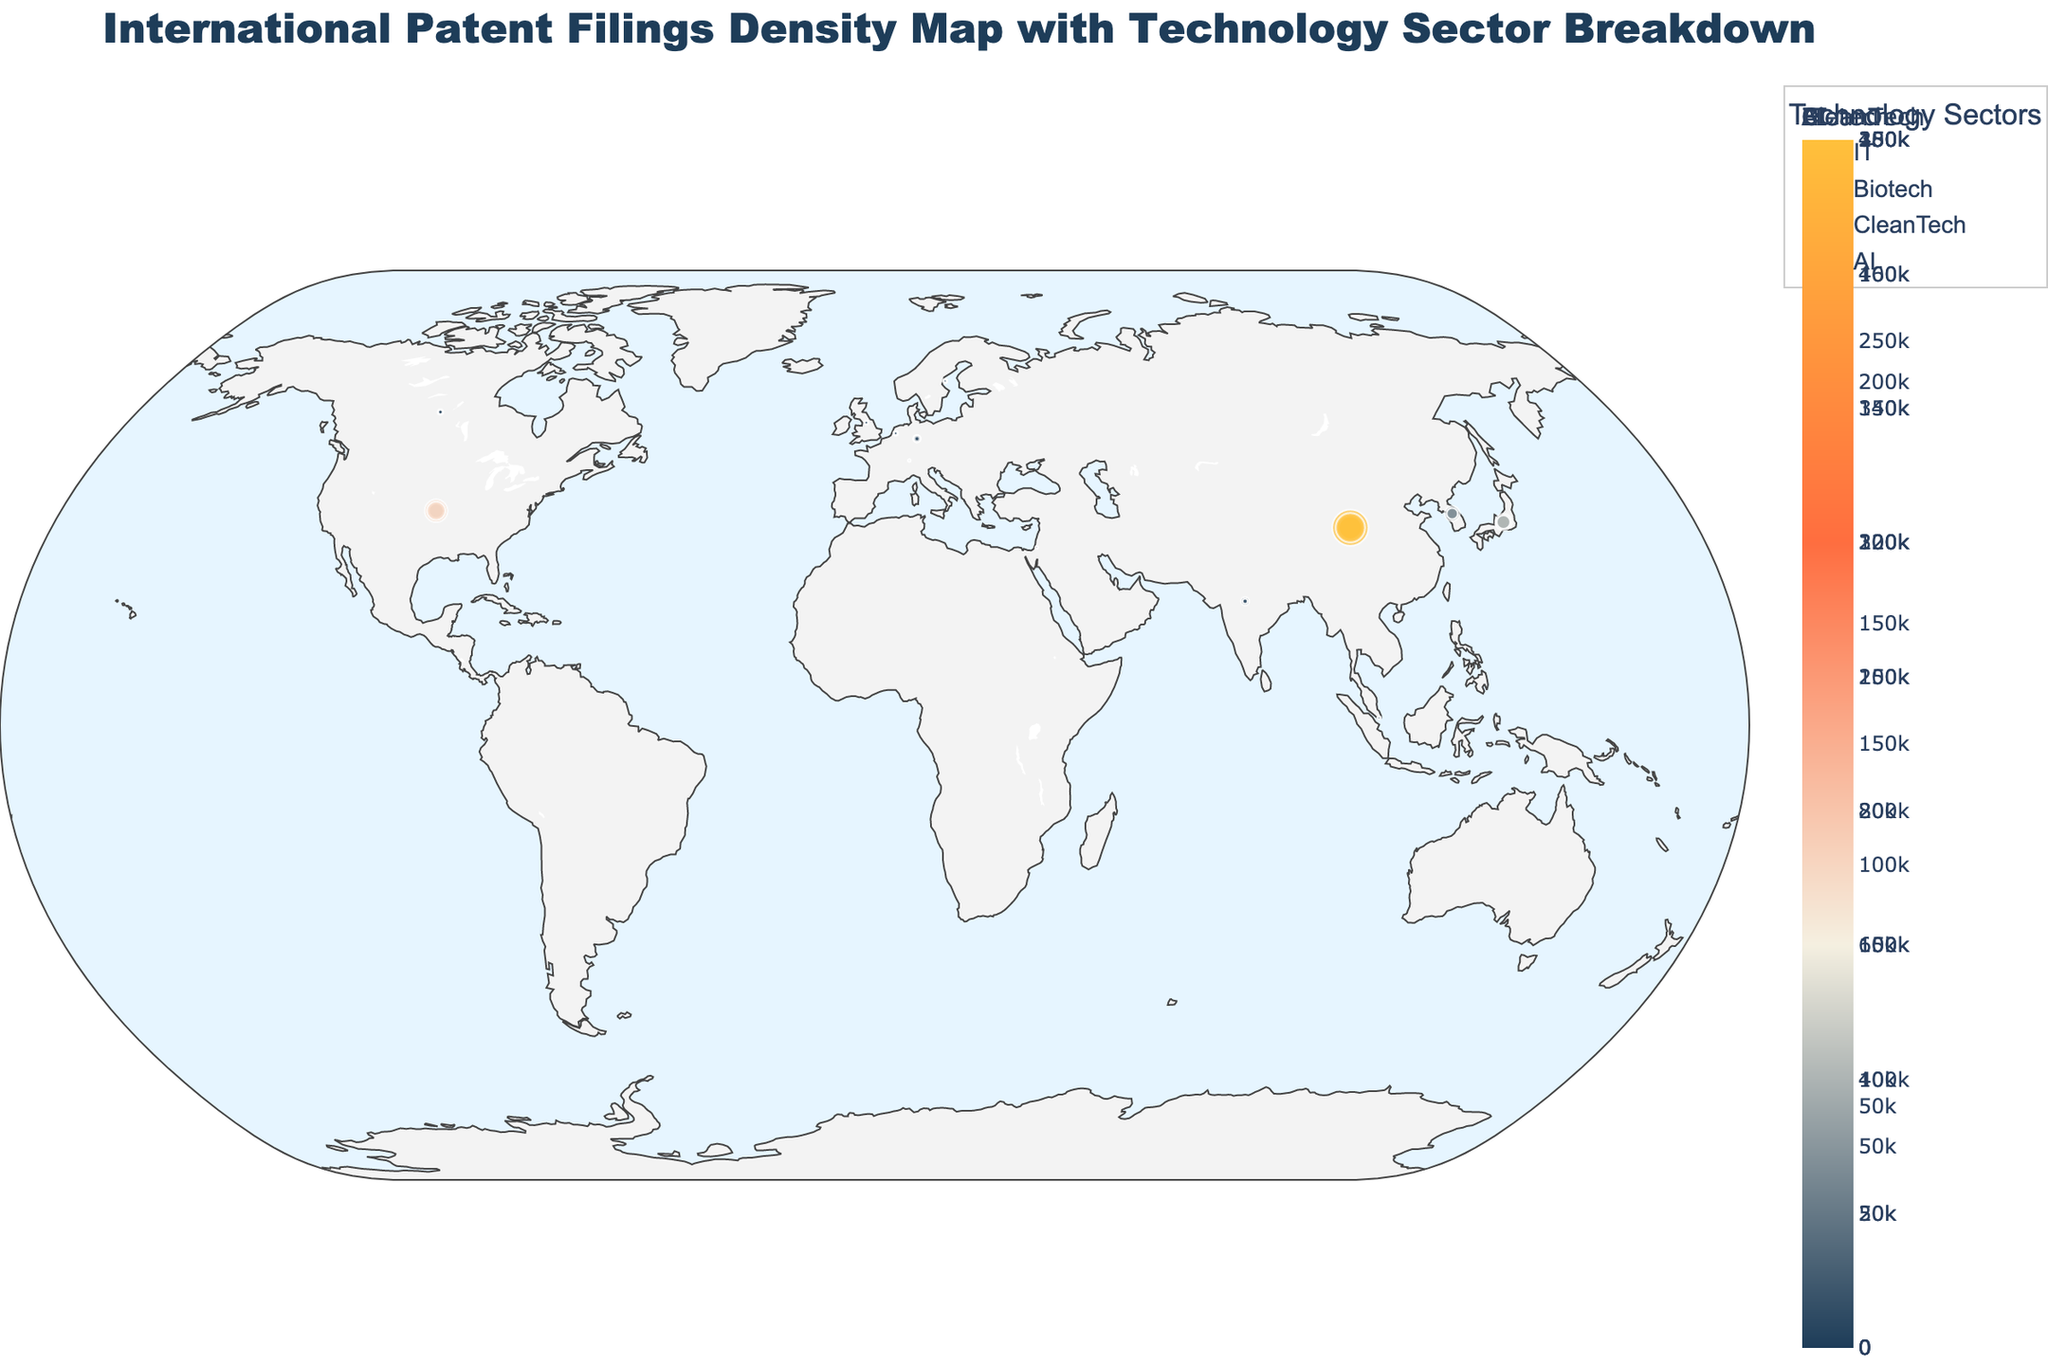What's the country with the highest AI patent filings? The figure shows the AI patent filings represented by marker size. Among the countries displayed, China has the largest marker size for AI filings.
Answer: China Which two countries have the smallest biotech patent filings? By comparing the sizes of the biotech markers, United Kingdom and Israel have the smallest biotech filings.
Answer: United Kingdom, Israel How many patents does Japan have in IT and Clean Tech combined? Japan has 95,000 IT patents and 60,000 Clean Tech patents. Adding these together: 95,000 + 60,000 = 155,000.
Answer: 155,000 Which sector does Germany have the most patents in? Observing the sizes of different sector markers for Germany, CleanTech has slightly larger markers compared to the other sectors.
Answer: CleanTech How does the number of CleanTech patents in the United States compare to those in China? Comparing CleanTech marker sizes, the United States has 75,000 patents whereas China has 250,000 patents, indicating China's CleanTech filings are significantly higher.
Answer: China has more What’s the proportion of IT patents to total patents for South Korea? South Korea has 80,000 IT patents and a total of 220,000 patents. The proportion is: 80,000 / 220,000 ≈ 0.36 or 36%.
Answer: 36% Which country in Europe has the highest CleanTech patent filings? From the figure, Germany exhibits the largest CleanTech marker in Europe.
Answer: Germany Are there more AI patents in India or Canada? Comparing AI marker sizes, India has a visibly larger marker in AI patents than Canada.
Answer: India How many total patents do Canada and the United Kingdom have together? Canada has 36,000 total patents and the United Kingdom has 20,000. Summing these: 36,000 + 20,000 = 56,000.
Answer: 56,000 What's the average number of Biotech patents for the countries listed? Summing Biotech patents: 95,000 (USA) + 180,000 (China) + 50,000 (Japan) + 30,000 (South Korea) + 15,000 (Germany) + 4,000 (UK) + 1,500 (Israel) + 8,000 (India) + 2,000 (Singapore) + 8,000 (Canada) + 2,500 (Switzerland) + 5,000 (Netherlands) + 4,000 (Sweden) = 405,000. There are 13 countries, so average: 405,000 / 13 ≈ 31,153.
Answer: 31,153 